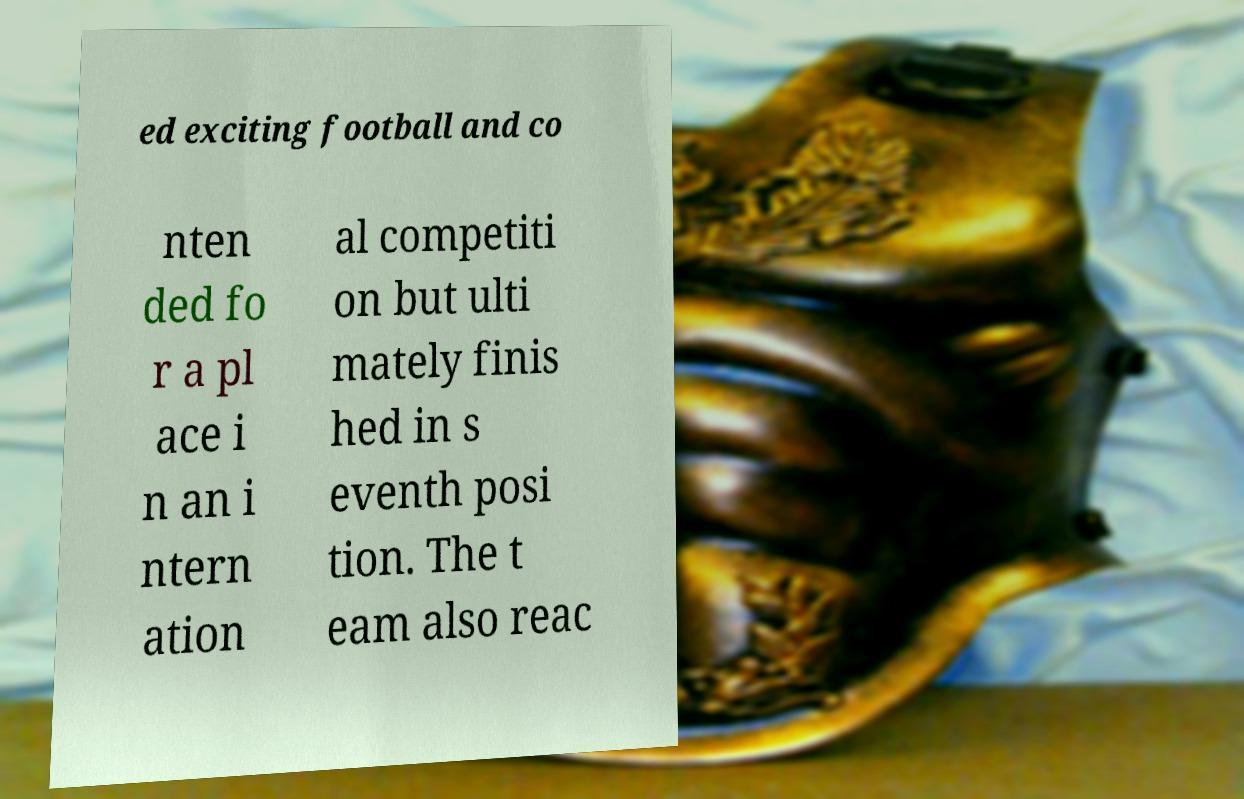Can you read and provide the text displayed in the image?This photo seems to have some interesting text. Can you extract and type it out for me? ed exciting football and co nten ded fo r a pl ace i n an i ntern ation al competiti on but ulti mately finis hed in s eventh posi tion. The t eam also reac 